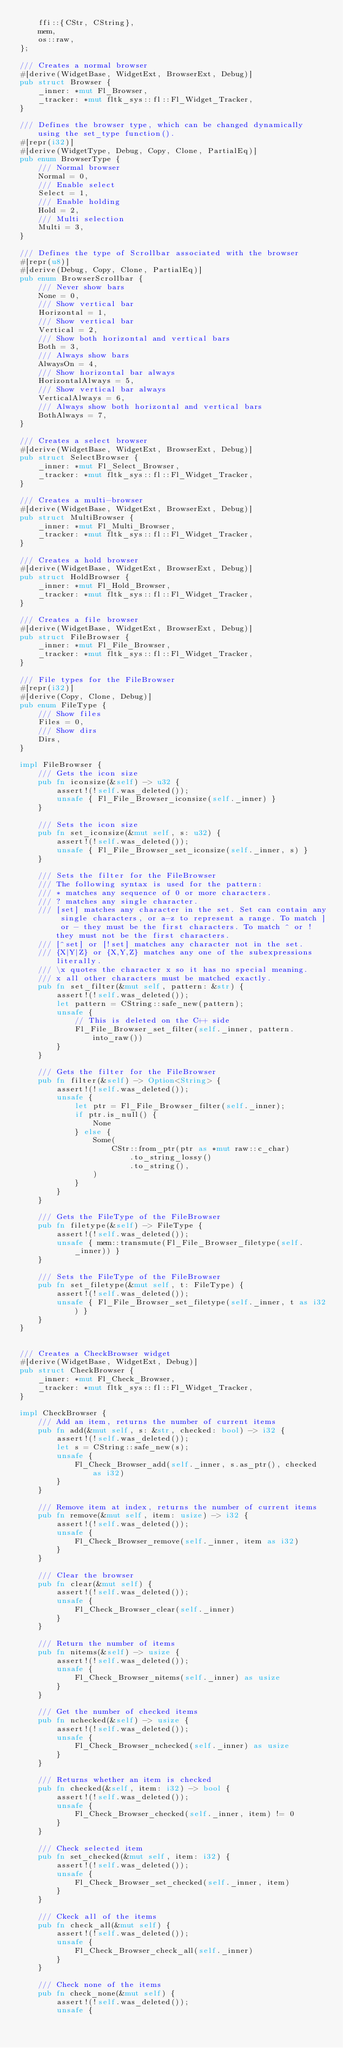Convert code to text. <code><loc_0><loc_0><loc_500><loc_500><_Rust_>    ffi::{CStr, CString},
    mem,
    os::raw,
};

/// Creates a normal browser
#[derive(WidgetBase, WidgetExt, BrowserExt, Debug)]
pub struct Browser {
    _inner: *mut Fl_Browser,
    _tracker: *mut fltk_sys::fl::Fl_Widget_Tracker,
}

/// Defines the browser type, which can be changed dynamically using the set_type function().
#[repr(i32)]
#[derive(WidgetType, Debug, Copy, Clone, PartialEq)]
pub enum BrowserType {
    /// Normal browser
    Normal = 0,
    /// Enable select
    Select = 1,
    /// Enable holding
    Hold = 2,
    /// Multi selection
    Multi = 3,
}

/// Defines the type of Scrollbar associated with the browser
#[repr(u8)]
#[derive(Debug, Copy, Clone, PartialEq)]
pub enum BrowserScrollbar {
    /// Never show bars
    None = 0,
    /// Show vertical bar
    Horizontal = 1,
    /// Show vertical bar
    Vertical = 2,
    /// Show both horizontal and vertical bars
    Both = 3,
    /// Always show bars
    AlwaysOn = 4,
    /// Show horizontal bar always
    HorizontalAlways = 5,
    /// Show vertical bar always
    VerticalAlways = 6,
    /// Always show both horizontal and vertical bars
    BothAlways = 7,
}

/// Creates a select browser
#[derive(WidgetBase, WidgetExt, BrowserExt, Debug)]
pub struct SelectBrowser {
    _inner: *mut Fl_Select_Browser,
    _tracker: *mut fltk_sys::fl::Fl_Widget_Tracker,
}

/// Creates a multi-browser
#[derive(WidgetBase, WidgetExt, BrowserExt, Debug)]
pub struct MultiBrowser {
    _inner: *mut Fl_Multi_Browser,
    _tracker: *mut fltk_sys::fl::Fl_Widget_Tracker,
}

/// Creates a hold browser
#[derive(WidgetBase, WidgetExt, BrowserExt, Debug)]
pub struct HoldBrowser {
    _inner: *mut Fl_Hold_Browser,
    _tracker: *mut fltk_sys::fl::Fl_Widget_Tracker,
}

/// Creates a file browser
#[derive(WidgetBase, WidgetExt, BrowserExt, Debug)]
pub struct FileBrowser {
    _inner: *mut Fl_File_Browser,
    _tracker: *mut fltk_sys::fl::Fl_Widget_Tracker,
}

/// File types for the FileBrowser
#[repr(i32)]
#[derive(Copy, Clone, Debug)]
pub enum FileType {
    /// Show files
    Files = 0,
    /// Show dirs
    Dirs,
}

impl FileBrowser {
    /// Gets the icon size
    pub fn iconsize(&self) -> u32 {
        assert!(!self.was_deleted());
        unsafe { Fl_File_Browser_iconsize(self._inner) }
    }

    /// Sets the icon size
    pub fn set_iconsize(&mut self, s: u32) {
        assert!(!self.was_deleted());
        unsafe { Fl_File_Browser_set_iconsize(self._inner, s) }
    }

    /// Sets the filter for the FileBrowser
    /// The following syntax is used for the pattern:
    /// * matches any sequence of 0 or more characters.
    /// ? matches any single character.
    /// [set] matches any character in the set. Set can contain any single characters, or a-z to represent a range. To match ] or - they must be the first characters. To match ^ or ! they must not be the first characters.
    /// [^set] or [!set] matches any character not in the set.
    /// {X|Y|Z} or {X,Y,Z} matches any one of the subexpressions literally.
    /// \x quotes the character x so it has no special meaning.
    /// x all other characters must be matched exactly.
    pub fn set_filter(&mut self, pattern: &str) {
        assert!(!self.was_deleted());
        let pattern = CString::safe_new(pattern);
        unsafe {
            // This is deleted on the C++ side
            Fl_File_Browser_set_filter(self._inner, pattern.into_raw())
        }
    }

    /// Gets the filter for the FileBrowser
    pub fn filter(&self) -> Option<String> {
        assert!(!self.was_deleted());
        unsafe {
            let ptr = Fl_File_Browser_filter(self._inner);
            if ptr.is_null() {
                None
            } else {
                Some(
                    CStr::from_ptr(ptr as *mut raw::c_char)
                        .to_string_lossy()
                        .to_string(),
                )
            }
        }
    }

    /// Gets the FileType of the FileBrowser
    pub fn filetype(&self) -> FileType {
        assert!(!self.was_deleted());
        unsafe { mem::transmute(Fl_File_Browser_filetype(self._inner)) }
    }

    /// Sets the FileType of the FileBrowser
    pub fn set_filetype(&mut self, t: FileType) {
        assert!(!self.was_deleted());
        unsafe { Fl_File_Browser_set_filetype(self._inner, t as i32) }
    }
}


/// Creates a CheckBrowser widget
#[derive(WidgetBase, WidgetExt, Debug)]
pub struct CheckBrowser {
    _inner: *mut Fl_Check_Browser,
    _tracker: *mut fltk_sys::fl::Fl_Widget_Tracker,
}

impl CheckBrowser {
    /// Add an item, returns the number of current items
    pub fn add(&mut self, s: &str, checked: bool) -> i32 {
        assert!(!self.was_deleted());
        let s = CString::safe_new(s);
        unsafe {
            Fl_Check_Browser_add(self._inner, s.as_ptr(), checked as i32)
        }
    }

    /// Remove item at index, returns the number of current items
    pub fn remove(&mut self, item: usize) -> i32 {
        assert!(!self.was_deleted());
        unsafe {
            Fl_Check_Browser_remove(self._inner, item as i32)
        }
    }

    /// Clear the browser
    pub fn clear(&mut self) {
        assert!(!self.was_deleted());
        unsafe {
            Fl_Check_Browser_clear(self._inner)
        }
    }

    /// Return the number of items
    pub fn nitems(&self) -> usize {
        assert!(!self.was_deleted());
        unsafe {
            Fl_Check_Browser_nitems(self._inner) as usize
        }
    }

    /// Get the number of checked items
    pub fn nchecked(&self) -> usize {
        assert!(!self.was_deleted());
        unsafe {
            Fl_Check_Browser_nchecked(self._inner) as usize
        }
    }

    /// Returns whether an item is checked
    pub fn checked(&self, item: i32) -> bool {
        assert!(!self.was_deleted());
        unsafe {
            Fl_Check_Browser_checked(self._inner, item) != 0
        }
    }

    /// Check selected item
    pub fn set_checked(&mut self, item: i32) {
        assert!(!self.was_deleted());
        unsafe {
            Fl_Check_Browser_set_checked(self._inner, item)
        }
    }

    /// Ckeck all of the items
    pub fn check_all(&mut self) {
        assert!(!self.was_deleted());
        unsafe {
            Fl_Check_Browser_check_all(self._inner)
        }
    }

    /// Check none of the items
    pub fn check_none(&mut self) {
        assert!(!self.was_deleted());
        unsafe {</code> 